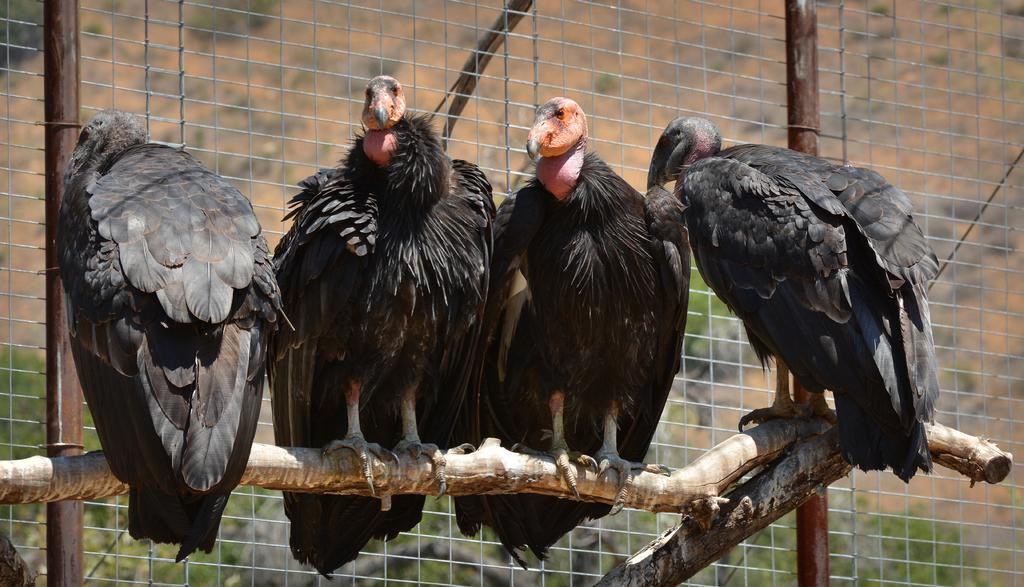What animals are in the center of the picture? There are falcons in the center of the picture. What are the falcons resting on? The falcons are on a wooden log. What can be seen in the middle of the image besides the falcons? There is fencing in the middle of the image. What type of natural environment is visible in the background of the image? Trees and soil are present in the background of the image. How many legs can be seen on the falcons in the image? Falcons do not have legs visible in the image; they are perched on a wooden log. Is there a stream visible in the background of the image? No, there is no stream present in the image; only trees and soil are visible in the background. 